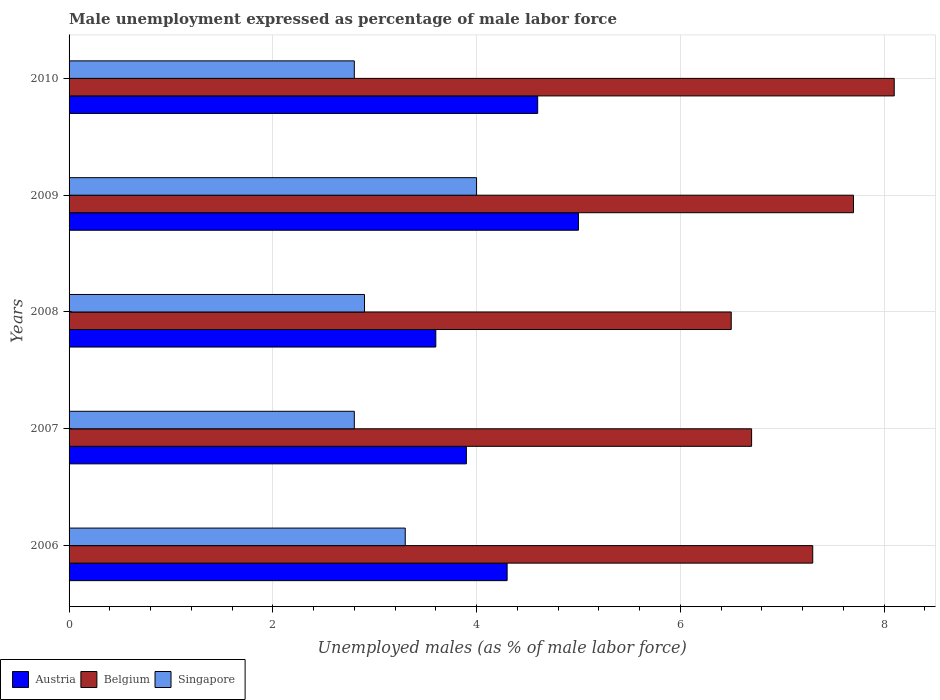How many different coloured bars are there?
Provide a short and direct response. 3. How many groups of bars are there?
Your response must be concise. 5. Are the number of bars per tick equal to the number of legend labels?
Provide a succinct answer. Yes. Are the number of bars on each tick of the Y-axis equal?
Ensure brevity in your answer.  Yes. How many bars are there on the 3rd tick from the top?
Make the answer very short. 3. What is the label of the 5th group of bars from the top?
Your response must be concise. 2006. What is the unemployment in males in in Austria in 2008?
Your answer should be very brief. 3.6. Across all years, what is the maximum unemployment in males in in Belgium?
Your response must be concise. 8.1. Across all years, what is the minimum unemployment in males in in Austria?
Provide a succinct answer. 3.6. In which year was the unemployment in males in in Belgium minimum?
Keep it short and to the point. 2008. What is the total unemployment in males in in Singapore in the graph?
Ensure brevity in your answer.  15.8. What is the difference between the unemployment in males in in Austria in 2008 and that in 2010?
Ensure brevity in your answer.  -1. What is the difference between the unemployment in males in in Austria in 2010 and the unemployment in males in in Belgium in 2009?
Give a very brief answer. -3.1. What is the average unemployment in males in in Austria per year?
Ensure brevity in your answer.  4.28. In the year 2006, what is the difference between the unemployment in males in in Austria and unemployment in males in in Singapore?
Give a very brief answer. 1. In how many years, is the unemployment in males in in Austria greater than 3.2 %?
Your answer should be very brief. 5. What is the ratio of the unemployment in males in in Singapore in 2008 to that in 2010?
Offer a very short reply. 1.04. Is the difference between the unemployment in males in in Austria in 2008 and 2009 greater than the difference between the unemployment in males in in Singapore in 2008 and 2009?
Your answer should be very brief. No. What is the difference between the highest and the second highest unemployment in males in in Austria?
Your answer should be very brief. 0.4. What is the difference between the highest and the lowest unemployment in males in in Belgium?
Your answer should be compact. 1.6. Is the sum of the unemployment in males in in Singapore in 2007 and 2008 greater than the maximum unemployment in males in in Austria across all years?
Provide a short and direct response. Yes. What does the 1st bar from the top in 2009 represents?
Your answer should be very brief. Singapore. What does the 2nd bar from the bottom in 2008 represents?
Offer a very short reply. Belgium. Are all the bars in the graph horizontal?
Offer a very short reply. Yes. What is the difference between two consecutive major ticks on the X-axis?
Make the answer very short. 2. Does the graph contain any zero values?
Your answer should be very brief. No. Does the graph contain grids?
Give a very brief answer. Yes. What is the title of the graph?
Provide a short and direct response. Male unemployment expressed as percentage of male labor force. Does "Honduras" appear as one of the legend labels in the graph?
Provide a short and direct response. No. What is the label or title of the X-axis?
Give a very brief answer. Unemployed males (as % of male labor force). What is the Unemployed males (as % of male labor force) in Austria in 2006?
Make the answer very short. 4.3. What is the Unemployed males (as % of male labor force) of Belgium in 2006?
Ensure brevity in your answer.  7.3. What is the Unemployed males (as % of male labor force) of Singapore in 2006?
Offer a very short reply. 3.3. What is the Unemployed males (as % of male labor force) of Austria in 2007?
Give a very brief answer. 3.9. What is the Unemployed males (as % of male labor force) in Belgium in 2007?
Ensure brevity in your answer.  6.7. What is the Unemployed males (as % of male labor force) in Singapore in 2007?
Ensure brevity in your answer.  2.8. What is the Unemployed males (as % of male labor force) in Austria in 2008?
Make the answer very short. 3.6. What is the Unemployed males (as % of male labor force) of Singapore in 2008?
Offer a terse response. 2.9. What is the Unemployed males (as % of male labor force) in Austria in 2009?
Keep it short and to the point. 5. What is the Unemployed males (as % of male labor force) of Belgium in 2009?
Your answer should be compact. 7.7. What is the Unemployed males (as % of male labor force) in Austria in 2010?
Provide a short and direct response. 4.6. What is the Unemployed males (as % of male labor force) in Belgium in 2010?
Provide a short and direct response. 8.1. What is the Unemployed males (as % of male labor force) in Singapore in 2010?
Provide a short and direct response. 2.8. Across all years, what is the maximum Unemployed males (as % of male labor force) in Austria?
Ensure brevity in your answer.  5. Across all years, what is the maximum Unemployed males (as % of male labor force) in Belgium?
Offer a terse response. 8.1. Across all years, what is the minimum Unemployed males (as % of male labor force) in Austria?
Ensure brevity in your answer.  3.6. Across all years, what is the minimum Unemployed males (as % of male labor force) in Belgium?
Offer a very short reply. 6.5. Across all years, what is the minimum Unemployed males (as % of male labor force) of Singapore?
Keep it short and to the point. 2.8. What is the total Unemployed males (as % of male labor force) of Austria in the graph?
Give a very brief answer. 21.4. What is the total Unemployed males (as % of male labor force) of Belgium in the graph?
Your answer should be very brief. 36.3. What is the total Unemployed males (as % of male labor force) in Singapore in the graph?
Your answer should be very brief. 15.8. What is the difference between the Unemployed males (as % of male labor force) in Austria in 2006 and that in 2007?
Provide a short and direct response. 0.4. What is the difference between the Unemployed males (as % of male labor force) in Belgium in 2006 and that in 2008?
Make the answer very short. 0.8. What is the difference between the Unemployed males (as % of male labor force) of Singapore in 2006 and that in 2008?
Your answer should be compact. 0.4. What is the difference between the Unemployed males (as % of male labor force) in Austria in 2006 and that in 2009?
Offer a very short reply. -0.7. What is the difference between the Unemployed males (as % of male labor force) of Belgium in 2006 and that in 2009?
Offer a terse response. -0.4. What is the difference between the Unemployed males (as % of male labor force) of Austria in 2006 and that in 2010?
Your answer should be compact. -0.3. What is the difference between the Unemployed males (as % of male labor force) in Singapore in 2006 and that in 2010?
Ensure brevity in your answer.  0.5. What is the difference between the Unemployed males (as % of male labor force) in Belgium in 2007 and that in 2008?
Keep it short and to the point. 0.2. What is the difference between the Unemployed males (as % of male labor force) in Singapore in 2007 and that in 2008?
Your answer should be compact. -0.1. What is the difference between the Unemployed males (as % of male labor force) in Belgium in 2007 and that in 2009?
Make the answer very short. -1. What is the difference between the Unemployed males (as % of male labor force) in Singapore in 2007 and that in 2010?
Your answer should be compact. 0. What is the difference between the Unemployed males (as % of male labor force) in Singapore in 2008 and that in 2009?
Provide a succinct answer. -1.1. What is the difference between the Unemployed males (as % of male labor force) in Austria in 2008 and that in 2010?
Give a very brief answer. -1. What is the difference between the Unemployed males (as % of male labor force) of Singapore in 2008 and that in 2010?
Your response must be concise. 0.1. What is the difference between the Unemployed males (as % of male labor force) in Singapore in 2009 and that in 2010?
Keep it short and to the point. 1.2. What is the difference between the Unemployed males (as % of male labor force) in Austria in 2006 and the Unemployed males (as % of male labor force) in Singapore in 2007?
Keep it short and to the point. 1.5. What is the difference between the Unemployed males (as % of male labor force) of Austria in 2006 and the Unemployed males (as % of male labor force) of Belgium in 2008?
Make the answer very short. -2.2. What is the difference between the Unemployed males (as % of male labor force) of Austria in 2006 and the Unemployed males (as % of male labor force) of Singapore in 2008?
Offer a very short reply. 1.4. What is the difference between the Unemployed males (as % of male labor force) in Belgium in 2006 and the Unemployed males (as % of male labor force) in Singapore in 2008?
Ensure brevity in your answer.  4.4. What is the difference between the Unemployed males (as % of male labor force) in Austria in 2006 and the Unemployed males (as % of male labor force) in Belgium in 2009?
Give a very brief answer. -3.4. What is the difference between the Unemployed males (as % of male labor force) in Austria in 2006 and the Unemployed males (as % of male labor force) in Singapore in 2009?
Your response must be concise. 0.3. What is the difference between the Unemployed males (as % of male labor force) of Austria in 2007 and the Unemployed males (as % of male labor force) of Belgium in 2008?
Ensure brevity in your answer.  -2.6. What is the difference between the Unemployed males (as % of male labor force) of Belgium in 2007 and the Unemployed males (as % of male labor force) of Singapore in 2008?
Offer a very short reply. 3.8. What is the difference between the Unemployed males (as % of male labor force) in Austria in 2007 and the Unemployed males (as % of male labor force) in Belgium in 2009?
Offer a terse response. -3.8. What is the difference between the Unemployed males (as % of male labor force) of Austria in 2007 and the Unemployed males (as % of male labor force) of Singapore in 2009?
Your response must be concise. -0.1. What is the difference between the Unemployed males (as % of male labor force) in Austria in 2007 and the Unemployed males (as % of male labor force) in Singapore in 2010?
Offer a very short reply. 1.1. What is the difference between the Unemployed males (as % of male labor force) in Austria in 2008 and the Unemployed males (as % of male labor force) in Singapore in 2009?
Give a very brief answer. -0.4. What is the difference between the Unemployed males (as % of male labor force) in Austria in 2009 and the Unemployed males (as % of male labor force) in Singapore in 2010?
Keep it short and to the point. 2.2. What is the difference between the Unemployed males (as % of male labor force) in Belgium in 2009 and the Unemployed males (as % of male labor force) in Singapore in 2010?
Your response must be concise. 4.9. What is the average Unemployed males (as % of male labor force) of Austria per year?
Offer a very short reply. 4.28. What is the average Unemployed males (as % of male labor force) of Belgium per year?
Ensure brevity in your answer.  7.26. What is the average Unemployed males (as % of male labor force) in Singapore per year?
Offer a very short reply. 3.16. In the year 2006, what is the difference between the Unemployed males (as % of male labor force) of Austria and Unemployed males (as % of male labor force) of Belgium?
Offer a very short reply. -3. In the year 2006, what is the difference between the Unemployed males (as % of male labor force) of Belgium and Unemployed males (as % of male labor force) of Singapore?
Offer a terse response. 4. In the year 2007, what is the difference between the Unemployed males (as % of male labor force) in Austria and Unemployed males (as % of male labor force) in Singapore?
Keep it short and to the point. 1.1. In the year 2008, what is the difference between the Unemployed males (as % of male labor force) of Austria and Unemployed males (as % of male labor force) of Belgium?
Offer a terse response. -2.9. In the year 2008, what is the difference between the Unemployed males (as % of male labor force) of Belgium and Unemployed males (as % of male labor force) of Singapore?
Your answer should be compact. 3.6. In the year 2009, what is the difference between the Unemployed males (as % of male labor force) in Belgium and Unemployed males (as % of male labor force) in Singapore?
Offer a terse response. 3.7. In the year 2010, what is the difference between the Unemployed males (as % of male labor force) in Austria and Unemployed males (as % of male labor force) in Belgium?
Your answer should be compact. -3.5. In the year 2010, what is the difference between the Unemployed males (as % of male labor force) in Austria and Unemployed males (as % of male labor force) in Singapore?
Your answer should be compact. 1.8. In the year 2010, what is the difference between the Unemployed males (as % of male labor force) in Belgium and Unemployed males (as % of male labor force) in Singapore?
Offer a terse response. 5.3. What is the ratio of the Unemployed males (as % of male labor force) of Austria in 2006 to that in 2007?
Provide a succinct answer. 1.1. What is the ratio of the Unemployed males (as % of male labor force) in Belgium in 2006 to that in 2007?
Give a very brief answer. 1.09. What is the ratio of the Unemployed males (as % of male labor force) in Singapore in 2006 to that in 2007?
Your answer should be very brief. 1.18. What is the ratio of the Unemployed males (as % of male labor force) of Austria in 2006 to that in 2008?
Give a very brief answer. 1.19. What is the ratio of the Unemployed males (as % of male labor force) of Belgium in 2006 to that in 2008?
Your answer should be compact. 1.12. What is the ratio of the Unemployed males (as % of male labor force) of Singapore in 2006 to that in 2008?
Offer a terse response. 1.14. What is the ratio of the Unemployed males (as % of male labor force) in Austria in 2006 to that in 2009?
Your answer should be very brief. 0.86. What is the ratio of the Unemployed males (as % of male labor force) in Belgium in 2006 to that in 2009?
Ensure brevity in your answer.  0.95. What is the ratio of the Unemployed males (as % of male labor force) in Singapore in 2006 to that in 2009?
Your response must be concise. 0.82. What is the ratio of the Unemployed males (as % of male labor force) in Austria in 2006 to that in 2010?
Ensure brevity in your answer.  0.93. What is the ratio of the Unemployed males (as % of male labor force) in Belgium in 2006 to that in 2010?
Your response must be concise. 0.9. What is the ratio of the Unemployed males (as % of male labor force) of Singapore in 2006 to that in 2010?
Your answer should be very brief. 1.18. What is the ratio of the Unemployed males (as % of male labor force) of Austria in 2007 to that in 2008?
Give a very brief answer. 1.08. What is the ratio of the Unemployed males (as % of male labor force) of Belgium in 2007 to that in 2008?
Offer a terse response. 1.03. What is the ratio of the Unemployed males (as % of male labor force) of Singapore in 2007 to that in 2008?
Offer a terse response. 0.97. What is the ratio of the Unemployed males (as % of male labor force) in Austria in 2007 to that in 2009?
Your response must be concise. 0.78. What is the ratio of the Unemployed males (as % of male labor force) of Belgium in 2007 to that in 2009?
Your response must be concise. 0.87. What is the ratio of the Unemployed males (as % of male labor force) of Singapore in 2007 to that in 2009?
Your answer should be compact. 0.7. What is the ratio of the Unemployed males (as % of male labor force) in Austria in 2007 to that in 2010?
Keep it short and to the point. 0.85. What is the ratio of the Unemployed males (as % of male labor force) in Belgium in 2007 to that in 2010?
Offer a terse response. 0.83. What is the ratio of the Unemployed males (as % of male labor force) in Austria in 2008 to that in 2009?
Make the answer very short. 0.72. What is the ratio of the Unemployed males (as % of male labor force) of Belgium in 2008 to that in 2009?
Provide a succinct answer. 0.84. What is the ratio of the Unemployed males (as % of male labor force) in Singapore in 2008 to that in 2009?
Your answer should be compact. 0.72. What is the ratio of the Unemployed males (as % of male labor force) of Austria in 2008 to that in 2010?
Make the answer very short. 0.78. What is the ratio of the Unemployed males (as % of male labor force) in Belgium in 2008 to that in 2010?
Your answer should be very brief. 0.8. What is the ratio of the Unemployed males (as % of male labor force) of Singapore in 2008 to that in 2010?
Give a very brief answer. 1.04. What is the ratio of the Unemployed males (as % of male labor force) in Austria in 2009 to that in 2010?
Keep it short and to the point. 1.09. What is the ratio of the Unemployed males (as % of male labor force) of Belgium in 2009 to that in 2010?
Keep it short and to the point. 0.95. What is the ratio of the Unemployed males (as % of male labor force) in Singapore in 2009 to that in 2010?
Provide a succinct answer. 1.43. What is the difference between the highest and the lowest Unemployed males (as % of male labor force) in Austria?
Offer a terse response. 1.4. What is the difference between the highest and the lowest Unemployed males (as % of male labor force) in Singapore?
Your response must be concise. 1.2. 